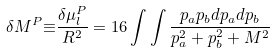Convert formula to latex. <formula><loc_0><loc_0><loc_500><loc_500>\delta M ^ { P } { \equiv } \frac { { \delta } { \mu } _ { l } ^ { P } } { R ^ { 2 } } = 1 6 \int \int \frac { p _ { a } p _ { b } d p _ { a } d p _ { b } } { p _ { a } ^ { 2 } + p _ { b } ^ { 2 } + M ^ { 2 } }</formula> 